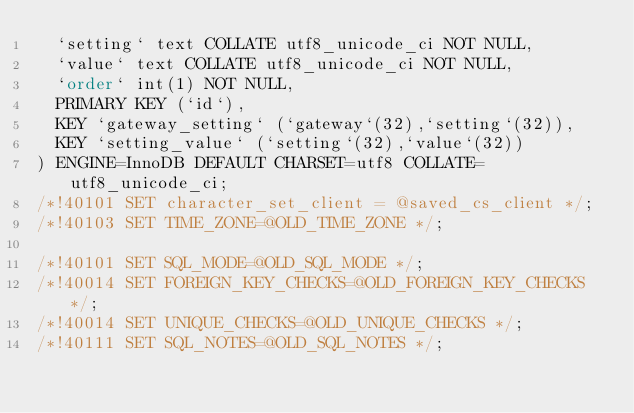Convert code to text. <code><loc_0><loc_0><loc_500><loc_500><_SQL_>  `setting` text COLLATE utf8_unicode_ci NOT NULL,
  `value` text COLLATE utf8_unicode_ci NOT NULL,
  `order` int(1) NOT NULL,
  PRIMARY KEY (`id`),
  KEY `gateway_setting` (`gateway`(32),`setting`(32)),
  KEY `setting_value` (`setting`(32),`value`(32))
) ENGINE=InnoDB DEFAULT CHARSET=utf8 COLLATE=utf8_unicode_ci;
/*!40101 SET character_set_client = @saved_cs_client */;
/*!40103 SET TIME_ZONE=@OLD_TIME_ZONE */;

/*!40101 SET SQL_MODE=@OLD_SQL_MODE */;
/*!40014 SET FOREIGN_KEY_CHECKS=@OLD_FOREIGN_KEY_CHECKS */;
/*!40014 SET UNIQUE_CHECKS=@OLD_UNIQUE_CHECKS */;
/*!40111 SET SQL_NOTES=@OLD_SQL_NOTES */;

</code> 